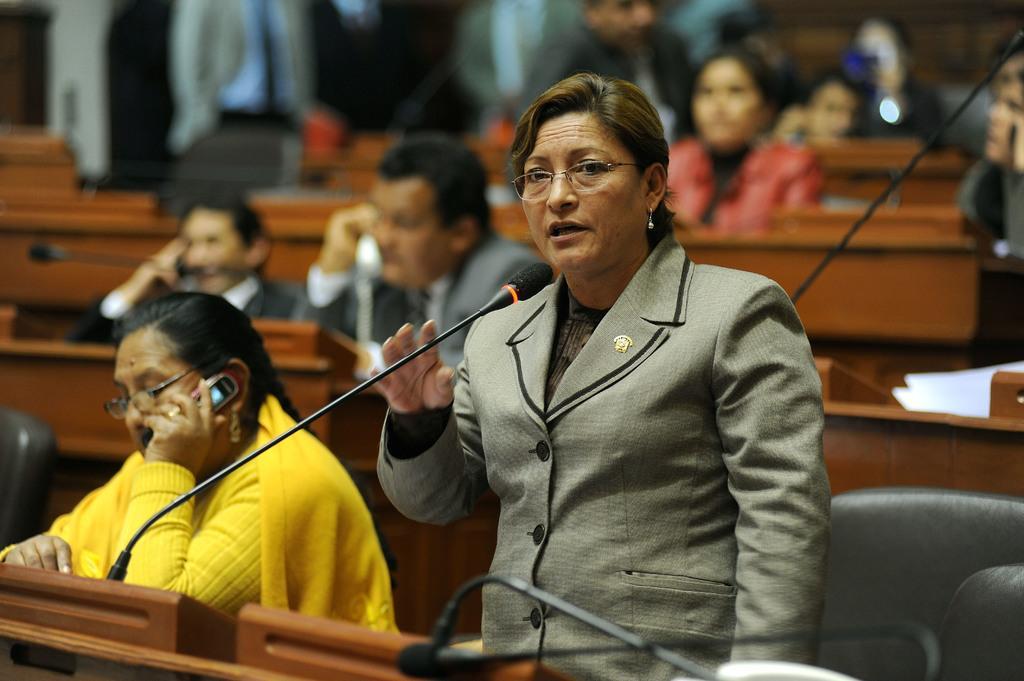How would you summarize this image in a sentence or two? In this picture I can see 2 women and I see that the woman on the right is standing and on the woman on the left is sitting. I can see tables in front of them on which there are mics. In the background I can see the chairs, few more tables on which there are mice and few more people. 